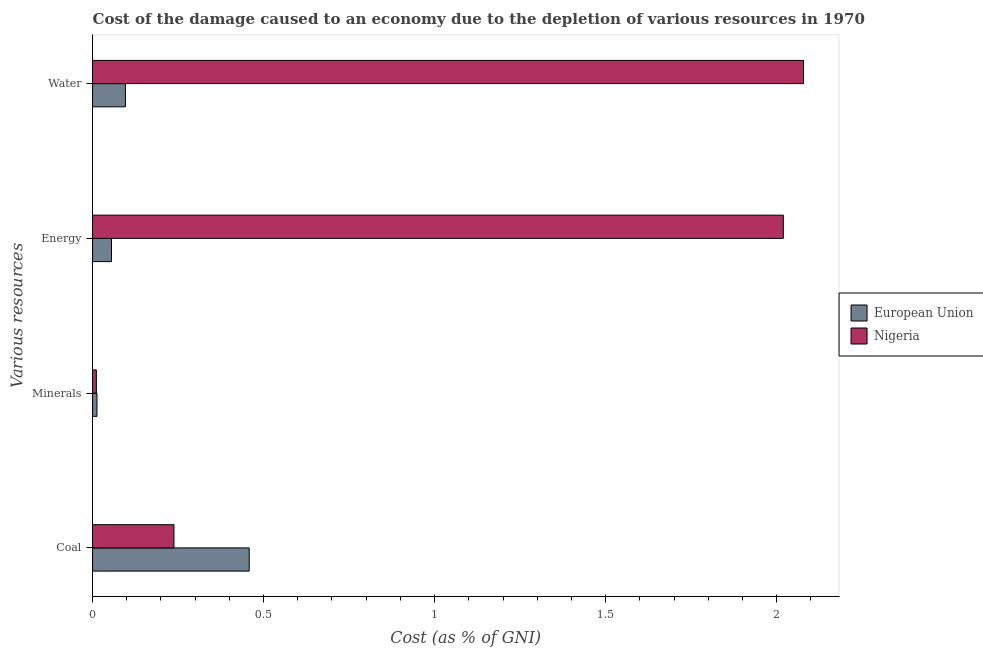How many different coloured bars are there?
Give a very brief answer. 2. How many bars are there on the 2nd tick from the top?
Keep it short and to the point. 2. How many bars are there on the 1st tick from the bottom?
Provide a succinct answer. 2. What is the label of the 3rd group of bars from the top?
Offer a terse response. Minerals. What is the cost of damage due to depletion of coal in Nigeria?
Keep it short and to the point. 0.24. Across all countries, what is the maximum cost of damage due to depletion of water?
Your response must be concise. 2.08. Across all countries, what is the minimum cost of damage due to depletion of minerals?
Provide a short and direct response. 0.01. What is the total cost of damage due to depletion of minerals in the graph?
Keep it short and to the point. 0.02. What is the difference between the cost of damage due to depletion of minerals in Nigeria and that in European Union?
Give a very brief answer. -0. What is the difference between the cost of damage due to depletion of water in Nigeria and the cost of damage due to depletion of minerals in European Union?
Give a very brief answer. 2.07. What is the average cost of damage due to depletion of energy per country?
Provide a short and direct response. 1.04. What is the difference between the cost of damage due to depletion of water and cost of damage due to depletion of energy in European Union?
Give a very brief answer. 0.04. What is the ratio of the cost of damage due to depletion of water in Nigeria to that in European Union?
Your response must be concise. 21.65. What is the difference between the highest and the second highest cost of damage due to depletion of minerals?
Provide a succinct answer. 0. What is the difference between the highest and the lowest cost of damage due to depletion of energy?
Keep it short and to the point. 1.96. What does the 1st bar from the top in Energy represents?
Offer a very short reply. Nigeria. Is it the case that in every country, the sum of the cost of damage due to depletion of coal and cost of damage due to depletion of minerals is greater than the cost of damage due to depletion of energy?
Make the answer very short. No. Are all the bars in the graph horizontal?
Your answer should be very brief. Yes. What is the difference between two consecutive major ticks on the X-axis?
Your response must be concise. 0.5. What is the title of the graph?
Offer a very short reply. Cost of the damage caused to an economy due to the depletion of various resources in 1970 . What is the label or title of the X-axis?
Provide a succinct answer. Cost (as % of GNI). What is the label or title of the Y-axis?
Your answer should be very brief. Various resources. What is the Cost (as % of GNI) in European Union in Coal?
Provide a short and direct response. 0.46. What is the Cost (as % of GNI) in Nigeria in Coal?
Provide a succinct answer. 0.24. What is the Cost (as % of GNI) in European Union in Minerals?
Provide a succinct answer. 0.01. What is the Cost (as % of GNI) in Nigeria in Minerals?
Provide a succinct answer. 0.01. What is the Cost (as % of GNI) of European Union in Energy?
Your response must be concise. 0.06. What is the Cost (as % of GNI) in Nigeria in Energy?
Your response must be concise. 2.02. What is the Cost (as % of GNI) of European Union in Water?
Your response must be concise. 0.1. What is the Cost (as % of GNI) of Nigeria in Water?
Offer a terse response. 2.08. Across all Various resources, what is the maximum Cost (as % of GNI) in European Union?
Provide a short and direct response. 0.46. Across all Various resources, what is the maximum Cost (as % of GNI) of Nigeria?
Give a very brief answer. 2.08. Across all Various resources, what is the minimum Cost (as % of GNI) in European Union?
Your answer should be compact. 0.01. Across all Various resources, what is the minimum Cost (as % of GNI) in Nigeria?
Give a very brief answer. 0.01. What is the total Cost (as % of GNI) of European Union in the graph?
Provide a succinct answer. 0.62. What is the total Cost (as % of GNI) of Nigeria in the graph?
Offer a terse response. 4.35. What is the difference between the Cost (as % of GNI) of European Union in Coal and that in Minerals?
Your answer should be compact. 0.45. What is the difference between the Cost (as % of GNI) of Nigeria in Coal and that in Minerals?
Give a very brief answer. 0.23. What is the difference between the Cost (as % of GNI) of European Union in Coal and that in Energy?
Offer a terse response. 0.4. What is the difference between the Cost (as % of GNI) in Nigeria in Coal and that in Energy?
Keep it short and to the point. -1.78. What is the difference between the Cost (as % of GNI) of European Union in Coal and that in Water?
Give a very brief answer. 0.36. What is the difference between the Cost (as % of GNI) of Nigeria in Coal and that in Water?
Your answer should be very brief. -1.84. What is the difference between the Cost (as % of GNI) in European Union in Minerals and that in Energy?
Ensure brevity in your answer.  -0.04. What is the difference between the Cost (as % of GNI) of Nigeria in Minerals and that in Energy?
Offer a terse response. -2.01. What is the difference between the Cost (as % of GNI) of European Union in Minerals and that in Water?
Your answer should be very brief. -0.08. What is the difference between the Cost (as % of GNI) in Nigeria in Minerals and that in Water?
Ensure brevity in your answer.  -2.07. What is the difference between the Cost (as % of GNI) of European Union in Energy and that in Water?
Your answer should be very brief. -0.04. What is the difference between the Cost (as % of GNI) in Nigeria in Energy and that in Water?
Ensure brevity in your answer.  -0.06. What is the difference between the Cost (as % of GNI) in European Union in Coal and the Cost (as % of GNI) in Nigeria in Minerals?
Keep it short and to the point. 0.45. What is the difference between the Cost (as % of GNI) of European Union in Coal and the Cost (as % of GNI) of Nigeria in Energy?
Provide a succinct answer. -1.56. What is the difference between the Cost (as % of GNI) in European Union in Coal and the Cost (as % of GNI) in Nigeria in Water?
Keep it short and to the point. -1.62. What is the difference between the Cost (as % of GNI) of European Union in Minerals and the Cost (as % of GNI) of Nigeria in Energy?
Offer a very short reply. -2.01. What is the difference between the Cost (as % of GNI) of European Union in Minerals and the Cost (as % of GNI) of Nigeria in Water?
Make the answer very short. -2.07. What is the difference between the Cost (as % of GNI) of European Union in Energy and the Cost (as % of GNI) of Nigeria in Water?
Ensure brevity in your answer.  -2.02. What is the average Cost (as % of GNI) of European Union per Various resources?
Your response must be concise. 0.16. What is the average Cost (as % of GNI) of Nigeria per Various resources?
Make the answer very short. 1.09. What is the difference between the Cost (as % of GNI) of European Union and Cost (as % of GNI) of Nigeria in Coal?
Give a very brief answer. 0.22. What is the difference between the Cost (as % of GNI) in European Union and Cost (as % of GNI) in Nigeria in Minerals?
Provide a succinct answer. 0. What is the difference between the Cost (as % of GNI) of European Union and Cost (as % of GNI) of Nigeria in Energy?
Offer a very short reply. -1.96. What is the difference between the Cost (as % of GNI) in European Union and Cost (as % of GNI) in Nigeria in Water?
Your answer should be compact. -1.98. What is the ratio of the Cost (as % of GNI) in European Union in Coal to that in Minerals?
Make the answer very short. 35.45. What is the ratio of the Cost (as % of GNI) of Nigeria in Coal to that in Minerals?
Keep it short and to the point. 21.37. What is the ratio of the Cost (as % of GNI) of European Union in Coal to that in Energy?
Your answer should be compact. 8.27. What is the ratio of the Cost (as % of GNI) of Nigeria in Coal to that in Energy?
Your answer should be compact. 0.12. What is the ratio of the Cost (as % of GNI) in European Union in Coal to that in Water?
Your response must be concise. 4.77. What is the ratio of the Cost (as % of GNI) in Nigeria in Coal to that in Water?
Give a very brief answer. 0.11. What is the ratio of the Cost (as % of GNI) in European Union in Minerals to that in Energy?
Your answer should be compact. 0.23. What is the ratio of the Cost (as % of GNI) in Nigeria in Minerals to that in Energy?
Ensure brevity in your answer.  0.01. What is the ratio of the Cost (as % of GNI) in European Union in Minerals to that in Water?
Provide a short and direct response. 0.13. What is the ratio of the Cost (as % of GNI) of Nigeria in Minerals to that in Water?
Offer a terse response. 0.01. What is the ratio of the Cost (as % of GNI) of European Union in Energy to that in Water?
Keep it short and to the point. 0.58. What is the ratio of the Cost (as % of GNI) in Nigeria in Energy to that in Water?
Offer a terse response. 0.97. What is the difference between the highest and the second highest Cost (as % of GNI) of European Union?
Your answer should be very brief. 0.36. What is the difference between the highest and the second highest Cost (as % of GNI) of Nigeria?
Your answer should be compact. 0.06. What is the difference between the highest and the lowest Cost (as % of GNI) in European Union?
Your response must be concise. 0.45. What is the difference between the highest and the lowest Cost (as % of GNI) of Nigeria?
Ensure brevity in your answer.  2.07. 